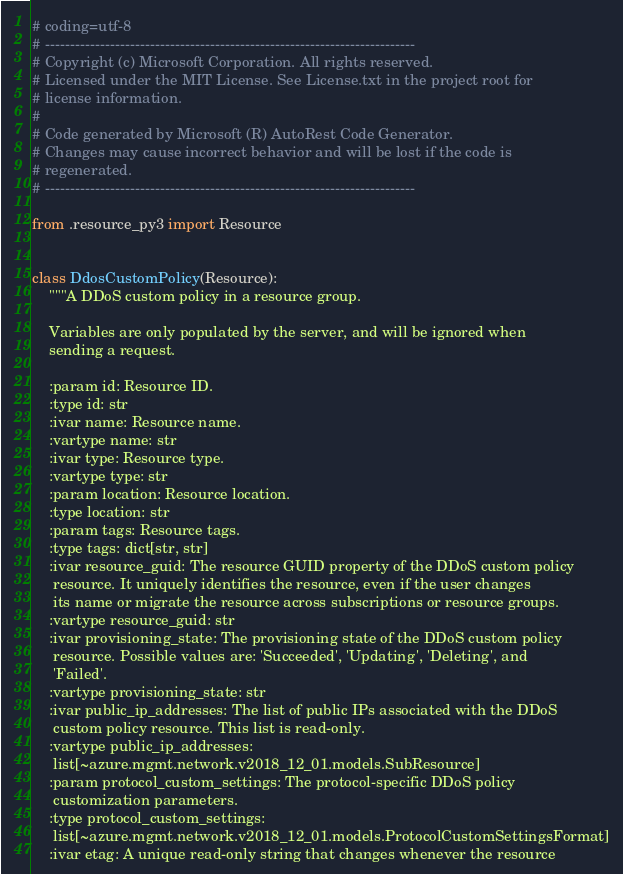<code> <loc_0><loc_0><loc_500><loc_500><_Python_># coding=utf-8
# --------------------------------------------------------------------------
# Copyright (c) Microsoft Corporation. All rights reserved.
# Licensed under the MIT License. See License.txt in the project root for
# license information.
#
# Code generated by Microsoft (R) AutoRest Code Generator.
# Changes may cause incorrect behavior and will be lost if the code is
# regenerated.
# --------------------------------------------------------------------------

from .resource_py3 import Resource


class DdosCustomPolicy(Resource):
    """A DDoS custom policy in a resource group.

    Variables are only populated by the server, and will be ignored when
    sending a request.

    :param id: Resource ID.
    :type id: str
    :ivar name: Resource name.
    :vartype name: str
    :ivar type: Resource type.
    :vartype type: str
    :param location: Resource location.
    :type location: str
    :param tags: Resource tags.
    :type tags: dict[str, str]
    :ivar resource_guid: The resource GUID property of the DDoS custom policy
     resource. It uniquely identifies the resource, even if the user changes
     its name or migrate the resource across subscriptions or resource groups.
    :vartype resource_guid: str
    :ivar provisioning_state: The provisioning state of the DDoS custom policy
     resource. Possible values are: 'Succeeded', 'Updating', 'Deleting', and
     'Failed'.
    :vartype provisioning_state: str
    :ivar public_ip_addresses: The list of public IPs associated with the DDoS
     custom policy resource. This list is read-only.
    :vartype public_ip_addresses:
     list[~azure.mgmt.network.v2018_12_01.models.SubResource]
    :param protocol_custom_settings: The protocol-specific DDoS policy
     customization parameters.
    :type protocol_custom_settings:
     list[~azure.mgmt.network.v2018_12_01.models.ProtocolCustomSettingsFormat]
    :ivar etag: A unique read-only string that changes whenever the resource</code> 